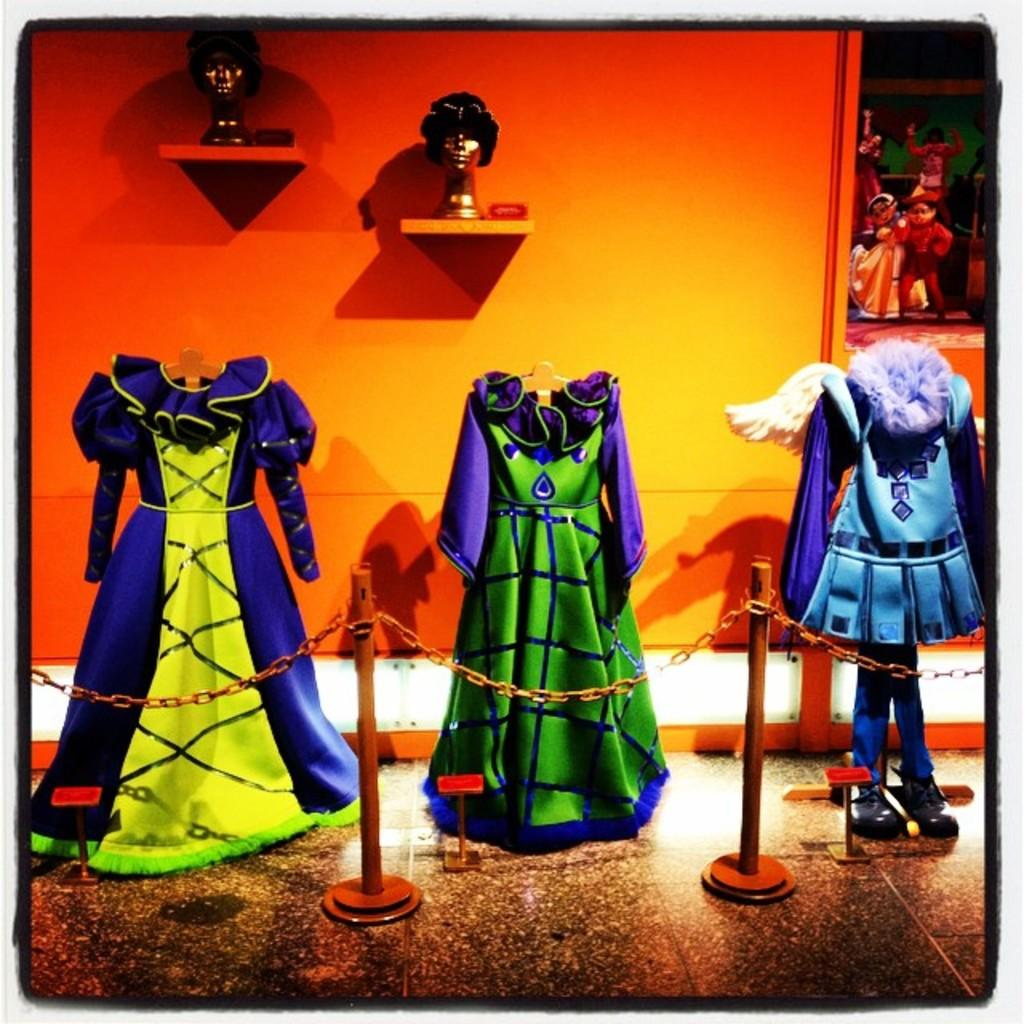What is located at the front of the image? There is a fence in the front of the image. What can be seen in the background of the image? There are clothes, idols, and toys in the background of the image. Where is the dock located in the image? There is no dock present in the image. What type of trail can be seen in the image? There is no trail present in the image. 